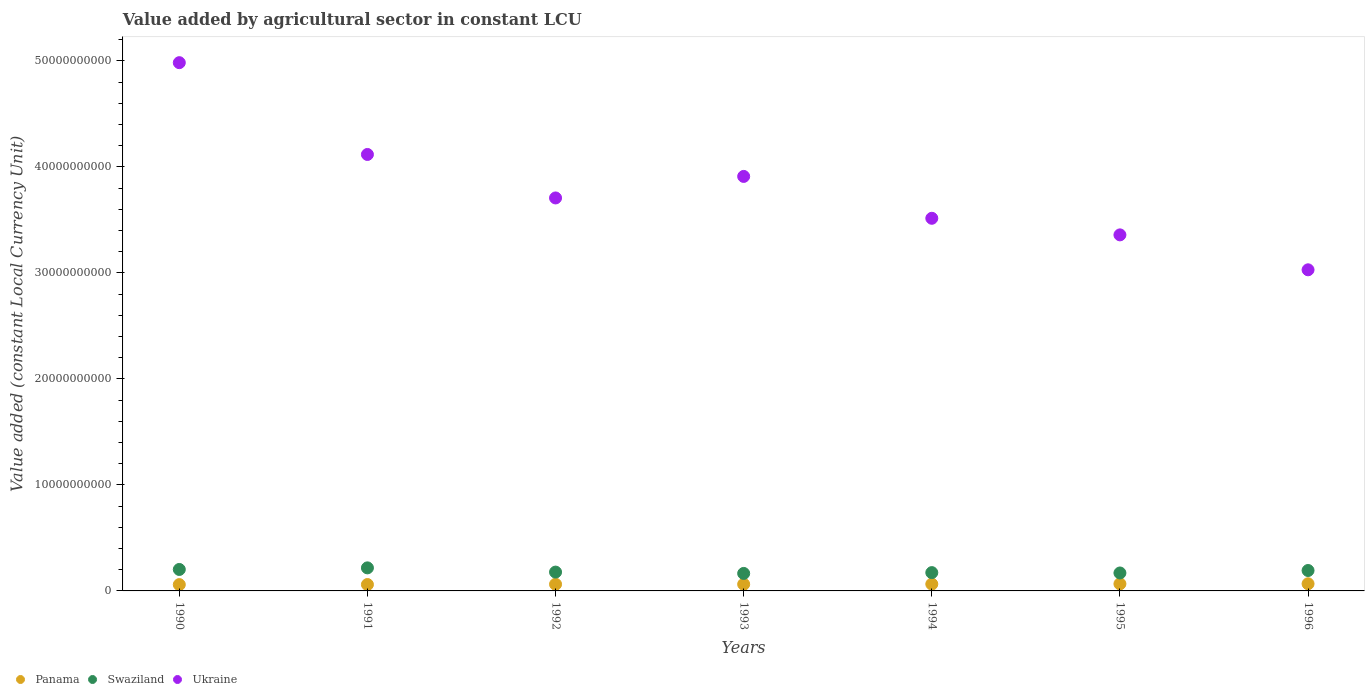What is the value added by agricultural sector in Swaziland in 1993?
Provide a short and direct response. 1.65e+09. Across all years, what is the maximum value added by agricultural sector in Panama?
Make the answer very short. 6.75e+08. Across all years, what is the minimum value added by agricultural sector in Panama?
Provide a succinct answer. 5.96e+08. In which year was the value added by agricultural sector in Panama maximum?
Give a very brief answer. 1996. In which year was the value added by agricultural sector in Swaziland minimum?
Your response must be concise. 1993. What is the total value added by agricultural sector in Panama in the graph?
Offer a terse response. 4.45e+09. What is the difference between the value added by agricultural sector in Ukraine in 1991 and that in 1996?
Ensure brevity in your answer.  1.09e+1. What is the difference between the value added by agricultural sector in Panama in 1991 and the value added by agricultural sector in Ukraine in 1996?
Your answer should be compact. -2.97e+1. What is the average value added by agricultural sector in Ukraine per year?
Your answer should be compact. 3.80e+1. In the year 1996, what is the difference between the value added by agricultural sector in Ukraine and value added by agricultural sector in Swaziland?
Make the answer very short. 2.84e+1. In how many years, is the value added by agricultural sector in Panama greater than 20000000000 LCU?
Offer a terse response. 0. What is the ratio of the value added by agricultural sector in Ukraine in 1992 to that in 1993?
Your answer should be compact. 0.95. Is the difference between the value added by agricultural sector in Ukraine in 1992 and 1993 greater than the difference between the value added by agricultural sector in Swaziland in 1992 and 1993?
Your answer should be compact. No. What is the difference between the highest and the second highest value added by agricultural sector in Swaziland?
Make the answer very short. 1.50e+08. What is the difference between the highest and the lowest value added by agricultural sector in Swaziland?
Make the answer very short. 5.24e+08. Is the sum of the value added by agricultural sector in Panama in 1991 and 1996 greater than the maximum value added by agricultural sector in Ukraine across all years?
Make the answer very short. No. Is it the case that in every year, the sum of the value added by agricultural sector in Panama and value added by agricultural sector in Swaziland  is greater than the value added by agricultural sector in Ukraine?
Your answer should be compact. No. Does the value added by agricultural sector in Panama monotonically increase over the years?
Give a very brief answer. Yes. Is the value added by agricultural sector in Panama strictly less than the value added by agricultural sector in Swaziland over the years?
Ensure brevity in your answer.  Yes. How many dotlines are there?
Make the answer very short. 3. How many years are there in the graph?
Your response must be concise. 7. Are the values on the major ticks of Y-axis written in scientific E-notation?
Your response must be concise. No. Where does the legend appear in the graph?
Provide a succinct answer. Bottom left. How many legend labels are there?
Provide a succinct answer. 3. How are the legend labels stacked?
Offer a terse response. Horizontal. What is the title of the graph?
Your answer should be very brief. Value added by agricultural sector in constant LCU. What is the label or title of the Y-axis?
Keep it short and to the point. Value added (constant Local Currency Unit). What is the Value added (constant Local Currency Unit) in Panama in 1990?
Give a very brief answer. 5.96e+08. What is the Value added (constant Local Currency Unit) of Swaziland in 1990?
Your response must be concise. 2.02e+09. What is the Value added (constant Local Currency Unit) of Ukraine in 1990?
Provide a succinct answer. 4.98e+1. What is the Value added (constant Local Currency Unit) in Panama in 1991?
Provide a succinct answer. 6.03e+08. What is the Value added (constant Local Currency Unit) in Swaziland in 1991?
Ensure brevity in your answer.  2.17e+09. What is the Value added (constant Local Currency Unit) of Ukraine in 1991?
Offer a very short reply. 4.12e+1. What is the Value added (constant Local Currency Unit) of Panama in 1992?
Your answer should be compact. 6.29e+08. What is the Value added (constant Local Currency Unit) of Swaziland in 1992?
Your answer should be very brief. 1.78e+09. What is the Value added (constant Local Currency Unit) of Ukraine in 1992?
Provide a short and direct response. 3.71e+1. What is the Value added (constant Local Currency Unit) of Panama in 1993?
Offer a very short reply. 6.29e+08. What is the Value added (constant Local Currency Unit) in Swaziland in 1993?
Your answer should be compact. 1.65e+09. What is the Value added (constant Local Currency Unit) in Ukraine in 1993?
Your answer should be very brief. 3.91e+1. What is the Value added (constant Local Currency Unit) of Panama in 1994?
Keep it short and to the point. 6.46e+08. What is the Value added (constant Local Currency Unit) in Swaziland in 1994?
Give a very brief answer. 1.73e+09. What is the Value added (constant Local Currency Unit) of Ukraine in 1994?
Ensure brevity in your answer.  3.52e+1. What is the Value added (constant Local Currency Unit) in Panama in 1995?
Provide a short and direct response. 6.67e+08. What is the Value added (constant Local Currency Unit) in Swaziland in 1995?
Provide a short and direct response. 1.69e+09. What is the Value added (constant Local Currency Unit) in Ukraine in 1995?
Make the answer very short. 3.36e+1. What is the Value added (constant Local Currency Unit) of Panama in 1996?
Your response must be concise. 6.75e+08. What is the Value added (constant Local Currency Unit) of Swaziland in 1996?
Offer a terse response. 1.93e+09. What is the Value added (constant Local Currency Unit) in Ukraine in 1996?
Give a very brief answer. 3.03e+1. Across all years, what is the maximum Value added (constant Local Currency Unit) of Panama?
Provide a short and direct response. 6.75e+08. Across all years, what is the maximum Value added (constant Local Currency Unit) of Swaziland?
Your answer should be very brief. 2.17e+09. Across all years, what is the maximum Value added (constant Local Currency Unit) of Ukraine?
Keep it short and to the point. 4.98e+1. Across all years, what is the minimum Value added (constant Local Currency Unit) in Panama?
Give a very brief answer. 5.96e+08. Across all years, what is the minimum Value added (constant Local Currency Unit) in Swaziland?
Your answer should be compact. 1.65e+09. Across all years, what is the minimum Value added (constant Local Currency Unit) of Ukraine?
Provide a succinct answer. 3.03e+1. What is the total Value added (constant Local Currency Unit) in Panama in the graph?
Provide a succinct answer. 4.45e+09. What is the total Value added (constant Local Currency Unit) of Swaziland in the graph?
Provide a succinct answer. 1.30e+1. What is the total Value added (constant Local Currency Unit) in Ukraine in the graph?
Offer a very short reply. 2.66e+11. What is the difference between the Value added (constant Local Currency Unit) in Panama in 1990 and that in 1991?
Your response must be concise. -6.42e+06. What is the difference between the Value added (constant Local Currency Unit) of Swaziland in 1990 and that in 1991?
Provide a short and direct response. -1.50e+08. What is the difference between the Value added (constant Local Currency Unit) in Ukraine in 1990 and that in 1991?
Make the answer very short. 8.66e+09. What is the difference between the Value added (constant Local Currency Unit) in Panama in 1990 and that in 1992?
Keep it short and to the point. -3.30e+07. What is the difference between the Value added (constant Local Currency Unit) of Swaziland in 1990 and that in 1992?
Your answer should be compact. 2.49e+08. What is the difference between the Value added (constant Local Currency Unit) in Ukraine in 1990 and that in 1992?
Provide a short and direct response. 1.28e+1. What is the difference between the Value added (constant Local Currency Unit) of Panama in 1990 and that in 1993?
Ensure brevity in your answer.  -3.33e+07. What is the difference between the Value added (constant Local Currency Unit) of Swaziland in 1990 and that in 1993?
Your answer should be compact. 3.74e+08. What is the difference between the Value added (constant Local Currency Unit) of Ukraine in 1990 and that in 1993?
Offer a terse response. 1.07e+1. What is the difference between the Value added (constant Local Currency Unit) in Panama in 1990 and that in 1994?
Provide a short and direct response. -5.02e+07. What is the difference between the Value added (constant Local Currency Unit) of Swaziland in 1990 and that in 1994?
Keep it short and to the point. 2.98e+08. What is the difference between the Value added (constant Local Currency Unit) of Ukraine in 1990 and that in 1994?
Make the answer very short. 1.47e+1. What is the difference between the Value added (constant Local Currency Unit) in Panama in 1990 and that in 1995?
Ensure brevity in your answer.  -7.10e+07. What is the difference between the Value added (constant Local Currency Unit) in Swaziland in 1990 and that in 1995?
Provide a short and direct response. 3.32e+08. What is the difference between the Value added (constant Local Currency Unit) of Ukraine in 1990 and that in 1995?
Provide a short and direct response. 1.62e+1. What is the difference between the Value added (constant Local Currency Unit) in Panama in 1990 and that in 1996?
Provide a succinct answer. -7.86e+07. What is the difference between the Value added (constant Local Currency Unit) of Swaziland in 1990 and that in 1996?
Provide a short and direct response. 9.90e+07. What is the difference between the Value added (constant Local Currency Unit) of Ukraine in 1990 and that in 1996?
Your answer should be compact. 1.95e+1. What is the difference between the Value added (constant Local Currency Unit) in Panama in 1991 and that in 1992?
Offer a terse response. -2.66e+07. What is the difference between the Value added (constant Local Currency Unit) of Swaziland in 1991 and that in 1992?
Ensure brevity in your answer.  3.98e+08. What is the difference between the Value added (constant Local Currency Unit) of Ukraine in 1991 and that in 1992?
Offer a very short reply. 4.10e+09. What is the difference between the Value added (constant Local Currency Unit) of Panama in 1991 and that in 1993?
Keep it short and to the point. -2.69e+07. What is the difference between the Value added (constant Local Currency Unit) of Swaziland in 1991 and that in 1993?
Offer a terse response. 5.24e+08. What is the difference between the Value added (constant Local Currency Unit) of Ukraine in 1991 and that in 1993?
Your answer should be very brief. 2.07e+09. What is the difference between the Value added (constant Local Currency Unit) of Panama in 1991 and that in 1994?
Offer a very short reply. -4.38e+07. What is the difference between the Value added (constant Local Currency Unit) of Swaziland in 1991 and that in 1994?
Give a very brief answer. 4.48e+08. What is the difference between the Value added (constant Local Currency Unit) of Ukraine in 1991 and that in 1994?
Make the answer very short. 6.02e+09. What is the difference between the Value added (constant Local Currency Unit) in Panama in 1991 and that in 1995?
Offer a very short reply. -6.46e+07. What is the difference between the Value added (constant Local Currency Unit) in Swaziland in 1991 and that in 1995?
Keep it short and to the point. 4.82e+08. What is the difference between the Value added (constant Local Currency Unit) in Ukraine in 1991 and that in 1995?
Your answer should be compact. 7.59e+09. What is the difference between the Value added (constant Local Currency Unit) of Panama in 1991 and that in 1996?
Keep it short and to the point. -7.22e+07. What is the difference between the Value added (constant Local Currency Unit) in Swaziland in 1991 and that in 1996?
Provide a succinct answer. 2.49e+08. What is the difference between the Value added (constant Local Currency Unit) of Ukraine in 1991 and that in 1996?
Offer a terse response. 1.09e+1. What is the difference between the Value added (constant Local Currency Unit) of Panama in 1992 and that in 1993?
Give a very brief answer. -2.62e+05. What is the difference between the Value added (constant Local Currency Unit) of Swaziland in 1992 and that in 1993?
Keep it short and to the point. 1.26e+08. What is the difference between the Value added (constant Local Currency Unit) in Ukraine in 1992 and that in 1993?
Your answer should be very brief. -2.03e+09. What is the difference between the Value added (constant Local Currency Unit) of Panama in 1992 and that in 1994?
Offer a very short reply. -1.72e+07. What is the difference between the Value added (constant Local Currency Unit) of Swaziland in 1992 and that in 1994?
Provide a short and direct response. 4.98e+07. What is the difference between the Value added (constant Local Currency Unit) in Ukraine in 1992 and that in 1994?
Provide a succinct answer. 1.92e+09. What is the difference between the Value added (constant Local Currency Unit) in Panama in 1992 and that in 1995?
Keep it short and to the point. -3.80e+07. What is the difference between the Value added (constant Local Currency Unit) of Swaziland in 1992 and that in 1995?
Your answer should be compact. 8.36e+07. What is the difference between the Value added (constant Local Currency Unit) of Ukraine in 1992 and that in 1995?
Give a very brief answer. 3.48e+09. What is the difference between the Value added (constant Local Currency Unit) in Panama in 1992 and that in 1996?
Ensure brevity in your answer.  -4.56e+07. What is the difference between the Value added (constant Local Currency Unit) of Swaziland in 1992 and that in 1996?
Give a very brief answer. -1.50e+08. What is the difference between the Value added (constant Local Currency Unit) of Ukraine in 1992 and that in 1996?
Give a very brief answer. 6.78e+09. What is the difference between the Value added (constant Local Currency Unit) in Panama in 1993 and that in 1994?
Keep it short and to the point. -1.69e+07. What is the difference between the Value added (constant Local Currency Unit) in Swaziland in 1993 and that in 1994?
Provide a short and direct response. -7.57e+07. What is the difference between the Value added (constant Local Currency Unit) in Ukraine in 1993 and that in 1994?
Your response must be concise. 3.95e+09. What is the difference between the Value added (constant Local Currency Unit) in Panama in 1993 and that in 1995?
Your answer should be compact. -3.77e+07. What is the difference between the Value added (constant Local Currency Unit) in Swaziland in 1993 and that in 1995?
Offer a very short reply. -4.19e+07. What is the difference between the Value added (constant Local Currency Unit) in Ukraine in 1993 and that in 1995?
Give a very brief answer. 5.51e+09. What is the difference between the Value added (constant Local Currency Unit) in Panama in 1993 and that in 1996?
Provide a short and direct response. -4.53e+07. What is the difference between the Value added (constant Local Currency Unit) in Swaziland in 1993 and that in 1996?
Ensure brevity in your answer.  -2.75e+08. What is the difference between the Value added (constant Local Currency Unit) of Ukraine in 1993 and that in 1996?
Your response must be concise. 8.81e+09. What is the difference between the Value added (constant Local Currency Unit) of Panama in 1994 and that in 1995?
Your response must be concise. -2.08e+07. What is the difference between the Value added (constant Local Currency Unit) of Swaziland in 1994 and that in 1995?
Provide a succinct answer. 3.38e+07. What is the difference between the Value added (constant Local Currency Unit) of Ukraine in 1994 and that in 1995?
Ensure brevity in your answer.  1.57e+09. What is the difference between the Value added (constant Local Currency Unit) of Panama in 1994 and that in 1996?
Your answer should be compact. -2.84e+07. What is the difference between the Value added (constant Local Currency Unit) in Swaziland in 1994 and that in 1996?
Your response must be concise. -1.99e+08. What is the difference between the Value added (constant Local Currency Unit) of Ukraine in 1994 and that in 1996?
Offer a very short reply. 4.86e+09. What is the difference between the Value added (constant Local Currency Unit) of Panama in 1995 and that in 1996?
Ensure brevity in your answer.  -7.60e+06. What is the difference between the Value added (constant Local Currency Unit) in Swaziland in 1995 and that in 1996?
Give a very brief answer. -2.33e+08. What is the difference between the Value added (constant Local Currency Unit) of Ukraine in 1995 and that in 1996?
Make the answer very short. 3.30e+09. What is the difference between the Value added (constant Local Currency Unit) in Panama in 1990 and the Value added (constant Local Currency Unit) in Swaziland in 1991?
Provide a succinct answer. -1.58e+09. What is the difference between the Value added (constant Local Currency Unit) of Panama in 1990 and the Value added (constant Local Currency Unit) of Ukraine in 1991?
Make the answer very short. -4.06e+1. What is the difference between the Value added (constant Local Currency Unit) in Swaziland in 1990 and the Value added (constant Local Currency Unit) in Ukraine in 1991?
Give a very brief answer. -3.91e+1. What is the difference between the Value added (constant Local Currency Unit) in Panama in 1990 and the Value added (constant Local Currency Unit) in Swaziland in 1992?
Your response must be concise. -1.18e+09. What is the difference between the Value added (constant Local Currency Unit) of Panama in 1990 and the Value added (constant Local Currency Unit) of Ukraine in 1992?
Offer a terse response. -3.65e+1. What is the difference between the Value added (constant Local Currency Unit) of Swaziland in 1990 and the Value added (constant Local Currency Unit) of Ukraine in 1992?
Your answer should be very brief. -3.50e+1. What is the difference between the Value added (constant Local Currency Unit) in Panama in 1990 and the Value added (constant Local Currency Unit) in Swaziland in 1993?
Offer a terse response. -1.05e+09. What is the difference between the Value added (constant Local Currency Unit) in Panama in 1990 and the Value added (constant Local Currency Unit) in Ukraine in 1993?
Make the answer very short. -3.85e+1. What is the difference between the Value added (constant Local Currency Unit) in Swaziland in 1990 and the Value added (constant Local Currency Unit) in Ukraine in 1993?
Provide a succinct answer. -3.71e+1. What is the difference between the Value added (constant Local Currency Unit) in Panama in 1990 and the Value added (constant Local Currency Unit) in Swaziland in 1994?
Offer a very short reply. -1.13e+09. What is the difference between the Value added (constant Local Currency Unit) of Panama in 1990 and the Value added (constant Local Currency Unit) of Ukraine in 1994?
Offer a very short reply. -3.46e+1. What is the difference between the Value added (constant Local Currency Unit) in Swaziland in 1990 and the Value added (constant Local Currency Unit) in Ukraine in 1994?
Offer a very short reply. -3.31e+1. What is the difference between the Value added (constant Local Currency Unit) in Panama in 1990 and the Value added (constant Local Currency Unit) in Swaziland in 1995?
Your response must be concise. -1.10e+09. What is the difference between the Value added (constant Local Currency Unit) of Panama in 1990 and the Value added (constant Local Currency Unit) of Ukraine in 1995?
Keep it short and to the point. -3.30e+1. What is the difference between the Value added (constant Local Currency Unit) of Swaziland in 1990 and the Value added (constant Local Currency Unit) of Ukraine in 1995?
Provide a short and direct response. -3.16e+1. What is the difference between the Value added (constant Local Currency Unit) in Panama in 1990 and the Value added (constant Local Currency Unit) in Swaziland in 1996?
Your response must be concise. -1.33e+09. What is the difference between the Value added (constant Local Currency Unit) in Panama in 1990 and the Value added (constant Local Currency Unit) in Ukraine in 1996?
Offer a terse response. -2.97e+1. What is the difference between the Value added (constant Local Currency Unit) of Swaziland in 1990 and the Value added (constant Local Currency Unit) of Ukraine in 1996?
Offer a very short reply. -2.83e+1. What is the difference between the Value added (constant Local Currency Unit) in Panama in 1991 and the Value added (constant Local Currency Unit) in Swaziland in 1992?
Provide a short and direct response. -1.17e+09. What is the difference between the Value added (constant Local Currency Unit) in Panama in 1991 and the Value added (constant Local Currency Unit) in Ukraine in 1992?
Offer a terse response. -3.65e+1. What is the difference between the Value added (constant Local Currency Unit) of Swaziland in 1991 and the Value added (constant Local Currency Unit) of Ukraine in 1992?
Make the answer very short. -3.49e+1. What is the difference between the Value added (constant Local Currency Unit) in Panama in 1991 and the Value added (constant Local Currency Unit) in Swaziland in 1993?
Offer a terse response. -1.05e+09. What is the difference between the Value added (constant Local Currency Unit) of Panama in 1991 and the Value added (constant Local Currency Unit) of Ukraine in 1993?
Your answer should be compact. -3.85e+1. What is the difference between the Value added (constant Local Currency Unit) in Swaziland in 1991 and the Value added (constant Local Currency Unit) in Ukraine in 1993?
Keep it short and to the point. -3.69e+1. What is the difference between the Value added (constant Local Currency Unit) in Panama in 1991 and the Value added (constant Local Currency Unit) in Swaziland in 1994?
Offer a terse response. -1.12e+09. What is the difference between the Value added (constant Local Currency Unit) in Panama in 1991 and the Value added (constant Local Currency Unit) in Ukraine in 1994?
Your answer should be compact. -3.46e+1. What is the difference between the Value added (constant Local Currency Unit) of Swaziland in 1991 and the Value added (constant Local Currency Unit) of Ukraine in 1994?
Keep it short and to the point. -3.30e+1. What is the difference between the Value added (constant Local Currency Unit) of Panama in 1991 and the Value added (constant Local Currency Unit) of Swaziland in 1995?
Provide a short and direct response. -1.09e+09. What is the difference between the Value added (constant Local Currency Unit) of Panama in 1991 and the Value added (constant Local Currency Unit) of Ukraine in 1995?
Offer a terse response. -3.30e+1. What is the difference between the Value added (constant Local Currency Unit) in Swaziland in 1991 and the Value added (constant Local Currency Unit) in Ukraine in 1995?
Your answer should be very brief. -3.14e+1. What is the difference between the Value added (constant Local Currency Unit) of Panama in 1991 and the Value added (constant Local Currency Unit) of Swaziland in 1996?
Offer a very short reply. -1.32e+09. What is the difference between the Value added (constant Local Currency Unit) in Panama in 1991 and the Value added (constant Local Currency Unit) in Ukraine in 1996?
Provide a short and direct response. -2.97e+1. What is the difference between the Value added (constant Local Currency Unit) of Swaziland in 1991 and the Value added (constant Local Currency Unit) of Ukraine in 1996?
Your answer should be compact. -2.81e+1. What is the difference between the Value added (constant Local Currency Unit) in Panama in 1992 and the Value added (constant Local Currency Unit) in Swaziland in 1993?
Offer a terse response. -1.02e+09. What is the difference between the Value added (constant Local Currency Unit) of Panama in 1992 and the Value added (constant Local Currency Unit) of Ukraine in 1993?
Provide a succinct answer. -3.85e+1. What is the difference between the Value added (constant Local Currency Unit) of Swaziland in 1992 and the Value added (constant Local Currency Unit) of Ukraine in 1993?
Offer a terse response. -3.73e+1. What is the difference between the Value added (constant Local Currency Unit) of Panama in 1992 and the Value added (constant Local Currency Unit) of Swaziland in 1994?
Your response must be concise. -1.10e+09. What is the difference between the Value added (constant Local Currency Unit) of Panama in 1992 and the Value added (constant Local Currency Unit) of Ukraine in 1994?
Offer a very short reply. -3.45e+1. What is the difference between the Value added (constant Local Currency Unit) in Swaziland in 1992 and the Value added (constant Local Currency Unit) in Ukraine in 1994?
Your answer should be compact. -3.34e+1. What is the difference between the Value added (constant Local Currency Unit) of Panama in 1992 and the Value added (constant Local Currency Unit) of Swaziland in 1995?
Make the answer very short. -1.06e+09. What is the difference between the Value added (constant Local Currency Unit) in Panama in 1992 and the Value added (constant Local Currency Unit) in Ukraine in 1995?
Keep it short and to the point. -3.30e+1. What is the difference between the Value added (constant Local Currency Unit) of Swaziland in 1992 and the Value added (constant Local Currency Unit) of Ukraine in 1995?
Offer a terse response. -3.18e+1. What is the difference between the Value added (constant Local Currency Unit) in Panama in 1992 and the Value added (constant Local Currency Unit) in Swaziland in 1996?
Provide a short and direct response. -1.30e+09. What is the difference between the Value added (constant Local Currency Unit) in Panama in 1992 and the Value added (constant Local Currency Unit) in Ukraine in 1996?
Your answer should be compact. -2.97e+1. What is the difference between the Value added (constant Local Currency Unit) in Swaziland in 1992 and the Value added (constant Local Currency Unit) in Ukraine in 1996?
Provide a short and direct response. -2.85e+1. What is the difference between the Value added (constant Local Currency Unit) of Panama in 1993 and the Value added (constant Local Currency Unit) of Swaziland in 1994?
Keep it short and to the point. -1.10e+09. What is the difference between the Value added (constant Local Currency Unit) of Panama in 1993 and the Value added (constant Local Currency Unit) of Ukraine in 1994?
Make the answer very short. -3.45e+1. What is the difference between the Value added (constant Local Currency Unit) in Swaziland in 1993 and the Value added (constant Local Currency Unit) in Ukraine in 1994?
Give a very brief answer. -3.35e+1. What is the difference between the Value added (constant Local Currency Unit) of Panama in 1993 and the Value added (constant Local Currency Unit) of Swaziland in 1995?
Provide a succinct answer. -1.06e+09. What is the difference between the Value added (constant Local Currency Unit) in Panama in 1993 and the Value added (constant Local Currency Unit) in Ukraine in 1995?
Provide a short and direct response. -3.30e+1. What is the difference between the Value added (constant Local Currency Unit) of Swaziland in 1993 and the Value added (constant Local Currency Unit) of Ukraine in 1995?
Provide a succinct answer. -3.19e+1. What is the difference between the Value added (constant Local Currency Unit) of Panama in 1993 and the Value added (constant Local Currency Unit) of Swaziland in 1996?
Provide a succinct answer. -1.30e+09. What is the difference between the Value added (constant Local Currency Unit) in Panama in 1993 and the Value added (constant Local Currency Unit) in Ukraine in 1996?
Provide a short and direct response. -2.97e+1. What is the difference between the Value added (constant Local Currency Unit) in Swaziland in 1993 and the Value added (constant Local Currency Unit) in Ukraine in 1996?
Provide a short and direct response. -2.86e+1. What is the difference between the Value added (constant Local Currency Unit) of Panama in 1994 and the Value added (constant Local Currency Unit) of Swaziland in 1995?
Provide a short and direct response. -1.05e+09. What is the difference between the Value added (constant Local Currency Unit) in Panama in 1994 and the Value added (constant Local Currency Unit) in Ukraine in 1995?
Provide a short and direct response. -3.29e+1. What is the difference between the Value added (constant Local Currency Unit) of Swaziland in 1994 and the Value added (constant Local Currency Unit) of Ukraine in 1995?
Offer a terse response. -3.19e+1. What is the difference between the Value added (constant Local Currency Unit) of Panama in 1994 and the Value added (constant Local Currency Unit) of Swaziland in 1996?
Offer a very short reply. -1.28e+09. What is the difference between the Value added (constant Local Currency Unit) in Panama in 1994 and the Value added (constant Local Currency Unit) in Ukraine in 1996?
Make the answer very short. -2.96e+1. What is the difference between the Value added (constant Local Currency Unit) of Swaziland in 1994 and the Value added (constant Local Currency Unit) of Ukraine in 1996?
Ensure brevity in your answer.  -2.86e+1. What is the difference between the Value added (constant Local Currency Unit) of Panama in 1995 and the Value added (constant Local Currency Unit) of Swaziland in 1996?
Provide a succinct answer. -1.26e+09. What is the difference between the Value added (constant Local Currency Unit) of Panama in 1995 and the Value added (constant Local Currency Unit) of Ukraine in 1996?
Offer a terse response. -2.96e+1. What is the difference between the Value added (constant Local Currency Unit) in Swaziland in 1995 and the Value added (constant Local Currency Unit) in Ukraine in 1996?
Your response must be concise. -2.86e+1. What is the average Value added (constant Local Currency Unit) of Panama per year?
Give a very brief answer. 6.35e+08. What is the average Value added (constant Local Currency Unit) of Swaziland per year?
Provide a succinct answer. 1.85e+09. What is the average Value added (constant Local Currency Unit) in Ukraine per year?
Provide a succinct answer. 3.80e+1. In the year 1990, what is the difference between the Value added (constant Local Currency Unit) of Panama and Value added (constant Local Currency Unit) of Swaziland?
Offer a very short reply. -1.43e+09. In the year 1990, what is the difference between the Value added (constant Local Currency Unit) in Panama and Value added (constant Local Currency Unit) in Ukraine?
Offer a terse response. -4.92e+1. In the year 1990, what is the difference between the Value added (constant Local Currency Unit) of Swaziland and Value added (constant Local Currency Unit) of Ukraine?
Your answer should be compact. -4.78e+1. In the year 1991, what is the difference between the Value added (constant Local Currency Unit) of Panama and Value added (constant Local Currency Unit) of Swaziland?
Your answer should be compact. -1.57e+09. In the year 1991, what is the difference between the Value added (constant Local Currency Unit) in Panama and Value added (constant Local Currency Unit) in Ukraine?
Give a very brief answer. -4.06e+1. In the year 1991, what is the difference between the Value added (constant Local Currency Unit) in Swaziland and Value added (constant Local Currency Unit) in Ukraine?
Your answer should be compact. -3.90e+1. In the year 1992, what is the difference between the Value added (constant Local Currency Unit) in Panama and Value added (constant Local Currency Unit) in Swaziland?
Offer a very short reply. -1.15e+09. In the year 1992, what is the difference between the Value added (constant Local Currency Unit) of Panama and Value added (constant Local Currency Unit) of Ukraine?
Give a very brief answer. -3.64e+1. In the year 1992, what is the difference between the Value added (constant Local Currency Unit) in Swaziland and Value added (constant Local Currency Unit) in Ukraine?
Your response must be concise. -3.53e+1. In the year 1993, what is the difference between the Value added (constant Local Currency Unit) of Panama and Value added (constant Local Currency Unit) of Swaziland?
Your answer should be very brief. -1.02e+09. In the year 1993, what is the difference between the Value added (constant Local Currency Unit) of Panama and Value added (constant Local Currency Unit) of Ukraine?
Offer a terse response. -3.85e+1. In the year 1993, what is the difference between the Value added (constant Local Currency Unit) in Swaziland and Value added (constant Local Currency Unit) in Ukraine?
Provide a short and direct response. -3.75e+1. In the year 1994, what is the difference between the Value added (constant Local Currency Unit) in Panama and Value added (constant Local Currency Unit) in Swaziland?
Ensure brevity in your answer.  -1.08e+09. In the year 1994, what is the difference between the Value added (constant Local Currency Unit) in Panama and Value added (constant Local Currency Unit) in Ukraine?
Ensure brevity in your answer.  -3.45e+1. In the year 1994, what is the difference between the Value added (constant Local Currency Unit) in Swaziland and Value added (constant Local Currency Unit) in Ukraine?
Offer a terse response. -3.34e+1. In the year 1995, what is the difference between the Value added (constant Local Currency Unit) in Panama and Value added (constant Local Currency Unit) in Swaziland?
Ensure brevity in your answer.  -1.03e+09. In the year 1995, what is the difference between the Value added (constant Local Currency Unit) of Panama and Value added (constant Local Currency Unit) of Ukraine?
Ensure brevity in your answer.  -3.29e+1. In the year 1995, what is the difference between the Value added (constant Local Currency Unit) of Swaziland and Value added (constant Local Currency Unit) of Ukraine?
Offer a very short reply. -3.19e+1. In the year 1996, what is the difference between the Value added (constant Local Currency Unit) in Panama and Value added (constant Local Currency Unit) in Swaziland?
Offer a terse response. -1.25e+09. In the year 1996, what is the difference between the Value added (constant Local Currency Unit) in Panama and Value added (constant Local Currency Unit) in Ukraine?
Offer a very short reply. -2.96e+1. In the year 1996, what is the difference between the Value added (constant Local Currency Unit) in Swaziland and Value added (constant Local Currency Unit) in Ukraine?
Your response must be concise. -2.84e+1. What is the ratio of the Value added (constant Local Currency Unit) of Panama in 1990 to that in 1991?
Your response must be concise. 0.99. What is the ratio of the Value added (constant Local Currency Unit) of Swaziland in 1990 to that in 1991?
Your response must be concise. 0.93. What is the ratio of the Value added (constant Local Currency Unit) of Ukraine in 1990 to that in 1991?
Keep it short and to the point. 1.21. What is the ratio of the Value added (constant Local Currency Unit) of Panama in 1990 to that in 1992?
Offer a terse response. 0.95. What is the ratio of the Value added (constant Local Currency Unit) in Swaziland in 1990 to that in 1992?
Provide a short and direct response. 1.14. What is the ratio of the Value added (constant Local Currency Unit) in Ukraine in 1990 to that in 1992?
Give a very brief answer. 1.34. What is the ratio of the Value added (constant Local Currency Unit) in Panama in 1990 to that in 1993?
Make the answer very short. 0.95. What is the ratio of the Value added (constant Local Currency Unit) of Swaziland in 1990 to that in 1993?
Provide a short and direct response. 1.23. What is the ratio of the Value added (constant Local Currency Unit) in Ukraine in 1990 to that in 1993?
Your answer should be very brief. 1.27. What is the ratio of the Value added (constant Local Currency Unit) of Panama in 1990 to that in 1994?
Keep it short and to the point. 0.92. What is the ratio of the Value added (constant Local Currency Unit) in Swaziland in 1990 to that in 1994?
Your answer should be very brief. 1.17. What is the ratio of the Value added (constant Local Currency Unit) of Ukraine in 1990 to that in 1994?
Give a very brief answer. 1.42. What is the ratio of the Value added (constant Local Currency Unit) in Panama in 1990 to that in 1995?
Your response must be concise. 0.89. What is the ratio of the Value added (constant Local Currency Unit) of Swaziland in 1990 to that in 1995?
Keep it short and to the point. 1.2. What is the ratio of the Value added (constant Local Currency Unit) of Ukraine in 1990 to that in 1995?
Your answer should be very brief. 1.48. What is the ratio of the Value added (constant Local Currency Unit) in Panama in 1990 to that in 1996?
Your answer should be very brief. 0.88. What is the ratio of the Value added (constant Local Currency Unit) in Swaziland in 1990 to that in 1996?
Provide a succinct answer. 1.05. What is the ratio of the Value added (constant Local Currency Unit) of Ukraine in 1990 to that in 1996?
Make the answer very short. 1.65. What is the ratio of the Value added (constant Local Currency Unit) of Panama in 1991 to that in 1992?
Ensure brevity in your answer.  0.96. What is the ratio of the Value added (constant Local Currency Unit) in Swaziland in 1991 to that in 1992?
Offer a very short reply. 1.22. What is the ratio of the Value added (constant Local Currency Unit) of Ukraine in 1991 to that in 1992?
Offer a terse response. 1.11. What is the ratio of the Value added (constant Local Currency Unit) in Panama in 1991 to that in 1993?
Offer a very short reply. 0.96. What is the ratio of the Value added (constant Local Currency Unit) of Swaziland in 1991 to that in 1993?
Offer a very short reply. 1.32. What is the ratio of the Value added (constant Local Currency Unit) of Ukraine in 1991 to that in 1993?
Your answer should be compact. 1.05. What is the ratio of the Value added (constant Local Currency Unit) in Panama in 1991 to that in 1994?
Provide a succinct answer. 0.93. What is the ratio of the Value added (constant Local Currency Unit) in Swaziland in 1991 to that in 1994?
Make the answer very short. 1.26. What is the ratio of the Value added (constant Local Currency Unit) of Ukraine in 1991 to that in 1994?
Offer a very short reply. 1.17. What is the ratio of the Value added (constant Local Currency Unit) of Panama in 1991 to that in 1995?
Provide a succinct answer. 0.9. What is the ratio of the Value added (constant Local Currency Unit) of Swaziland in 1991 to that in 1995?
Your answer should be very brief. 1.28. What is the ratio of the Value added (constant Local Currency Unit) of Ukraine in 1991 to that in 1995?
Provide a succinct answer. 1.23. What is the ratio of the Value added (constant Local Currency Unit) of Panama in 1991 to that in 1996?
Make the answer very short. 0.89. What is the ratio of the Value added (constant Local Currency Unit) of Swaziland in 1991 to that in 1996?
Your response must be concise. 1.13. What is the ratio of the Value added (constant Local Currency Unit) in Ukraine in 1991 to that in 1996?
Your answer should be compact. 1.36. What is the ratio of the Value added (constant Local Currency Unit) in Swaziland in 1992 to that in 1993?
Offer a very short reply. 1.08. What is the ratio of the Value added (constant Local Currency Unit) in Ukraine in 1992 to that in 1993?
Your answer should be compact. 0.95. What is the ratio of the Value added (constant Local Currency Unit) of Panama in 1992 to that in 1994?
Give a very brief answer. 0.97. What is the ratio of the Value added (constant Local Currency Unit) in Swaziland in 1992 to that in 1994?
Keep it short and to the point. 1.03. What is the ratio of the Value added (constant Local Currency Unit) of Ukraine in 1992 to that in 1994?
Provide a succinct answer. 1.05. What is the ratio of the Value added (constant Local Currency Unit) of Panama in 1992 to that in 1995?
Keep it short and to the point. 0.94. What is the ratio of the Value added (constant Local Currency Unit) in Swaziland in 1992 to that in 1995?
Provide a succinct answer. 1.05. What is the ratio of the Value added (constant Local Currency Unit) in Ukraine in 1992 to that in 1995?
Offer a very short reply. 1.1. What is the ratio of the Value added (constant Local Currency Unit) in Panama in 1992 to that in 1996?
Your response must be concise. 0.93. What is the ratio of the Value added (constant Local Currency Unit) in Swaziland in 1992 to that in 1996?
Give a very brief answer. 0.92. What is the ratio of the Value added (constant Local Currency Unit) in Ukraine in 1992 to that in 1996?
Give a very brief answer. 1.22. What is the ratio of the Value added (constant Local Currency Unit) of Panama in 1993 to that in 1994?
Give a very brief answer. 0.97. What is the ratio of the Value added (constant Local Currency Unit) of Swaziland in 1993 to that in 1994?
Keep it short and to the point. 0.96. What is the ratio of the Value added (constant Local Currency Unit) in Ukraine in 1993 to that in 1994?
Your answer should be compact. 1.11. What is the ratio of the Value added (constant Local Currency Unit) of Panama in 1993 to that in 1995?
Make the answer very short. 0.94. What is the ratio of the Value added (constant Local Currency Unit) in Swaziland in 1993 to that in 1995?
Your response must be concise. 0.98. What is the ratio of the Value added (constant Local Currency Unit) of Ukraine in 1993 to that in 1995?
Offer a terse response. 1.16. What is the ratio of the Value added (constant Local Currency Unit) of Panama in 1993 to that in 1996?
Your answer should be compact. 0.93. What is the ratio of the Value added (constant Local Currency Unit) of Swaziland in 1993 to that in 1996?
Your response must be concise. 0.86. What is the ratio of the Value added (constant Local Currency Unit) of Ukraine in 1993 to that in 1996?
Make the answer very short. 1.29. What is the ratio of the Value added (constant Local Currency Unit) of Panama in 1994 to that in 1995?
Provide a short and direct response. 0.97. What is the ratio of the Value added (constant Local Currency Unit) in Ukraine in 1994 to that in 1995?
Offer a very short reply. 1.05. What is the ratio of the Value added (constant Local Currency Unit) of Panama in 1994 to that in 1996?
Provide a short and direct response. 0.96. What is the ratio of the Value added (constant Local Currency Unit) in Swaziland in 1994 to that in 1996?
Provide a succinct answer. 0.9. What is the ratio of the Value added (constant Local Currency Unit) of Ukraine in 1994 to that in 1996?
Keep it short and to the point. 1.16. What is the ratio of the Value added (constant Local Currency Unit) in Panama in 1995 to that in 1996?
Make the answer very short. 0.99. What is the ratio of the Value added (constant Local Currency Unit) in Swaziland in 1995 to that in 1996?
Provide a short and direct response. 0.88. What is the ratio of the Value added (constant Local Currency Unit) in Ukraine in 1995 to that in 1996?
Make the answer very short. 1.11. What is the difference between the highest and the second highest Value added (constant Local Currency Unit) in Panama?
Your answer should be very brief. 7.60e+06. What is the difference between the highest and the second highest Value added (constant Local Currency Unit) in Swaziland?
Offer a very short reply. 1.50e+08. What is the difference between the highest and the second highest Value added (constant Local Currency Unit) in Ukraine?
Provide a succinct answer. 8.66e+09. What is the difference between the highest and the lowest Value added (constant Local Currency Unit) of Panama?
Give a very brief answer. 7.86e+07. What is the difference between the highest and the lowest Value added (constant Local Currency Unit) in Swaziland?
Offer a very short reply. 5.24e+08. What is the difference between the highest and the lowest Value added (constant Local Currency Unit) of Ukraine?
Your answer should be compact. 1.95e+1. 